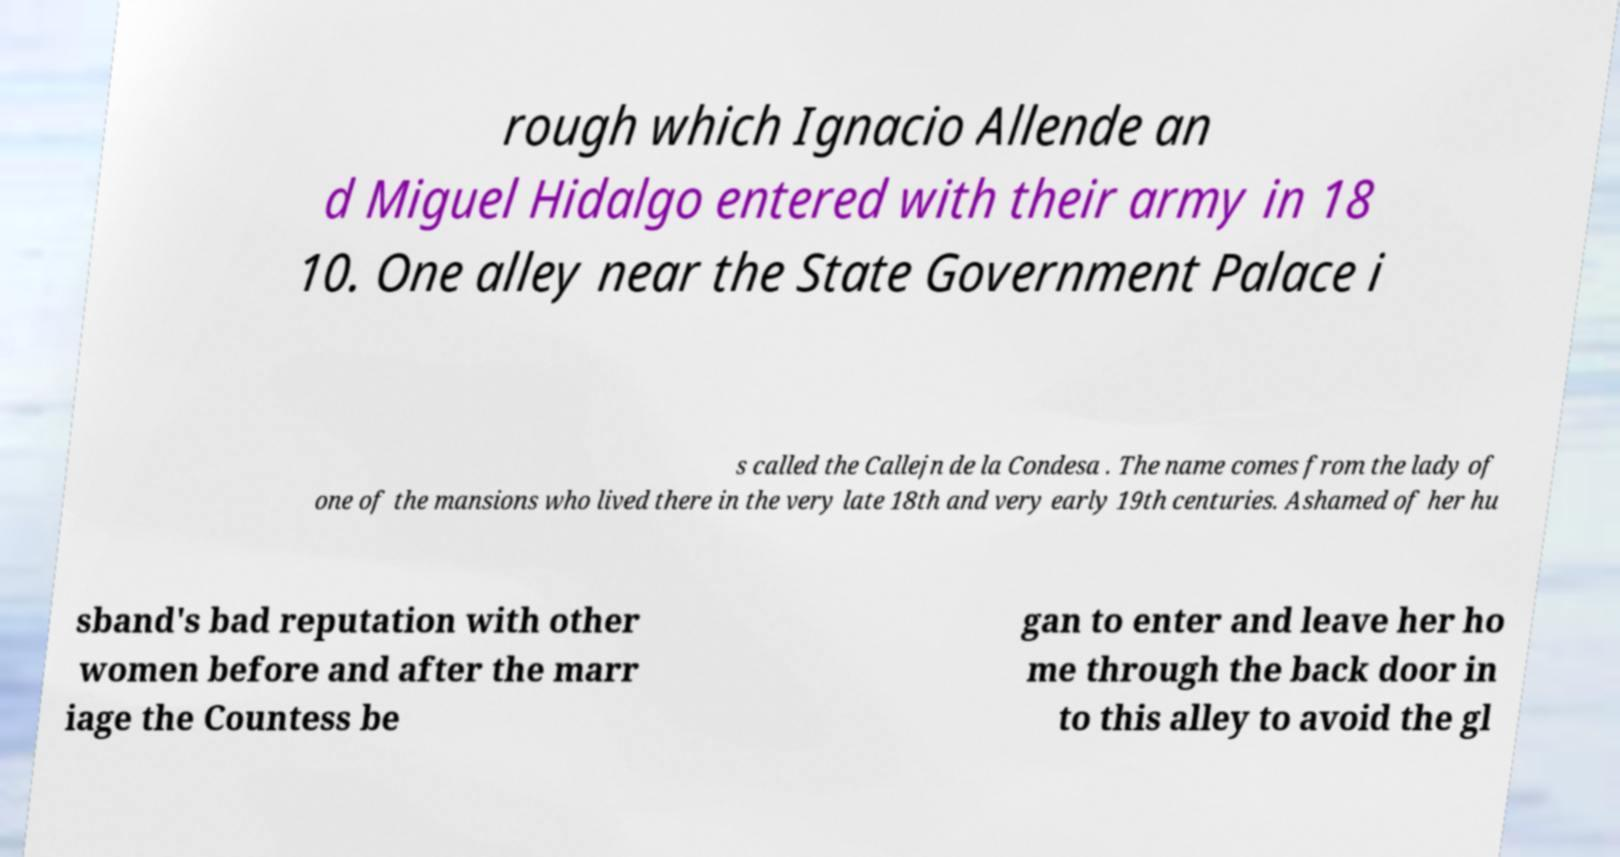Can you accurately transcribe the text from the provided image for me? rough which Ignacio Allende an d Miguel Hidalgo entered with their army in 18 10. One alley near the State Government Palace i s called the Callejn de la Condesa . The name comes from the lady of one of the mansions who lived there in the very late 18th and very early 19th centuries. Ashamed of her hu sband's bad reputation with other women before and after the marr iage the Countess be gan to enter and leave her ho me through the back door in to this alley to avoid the gl 